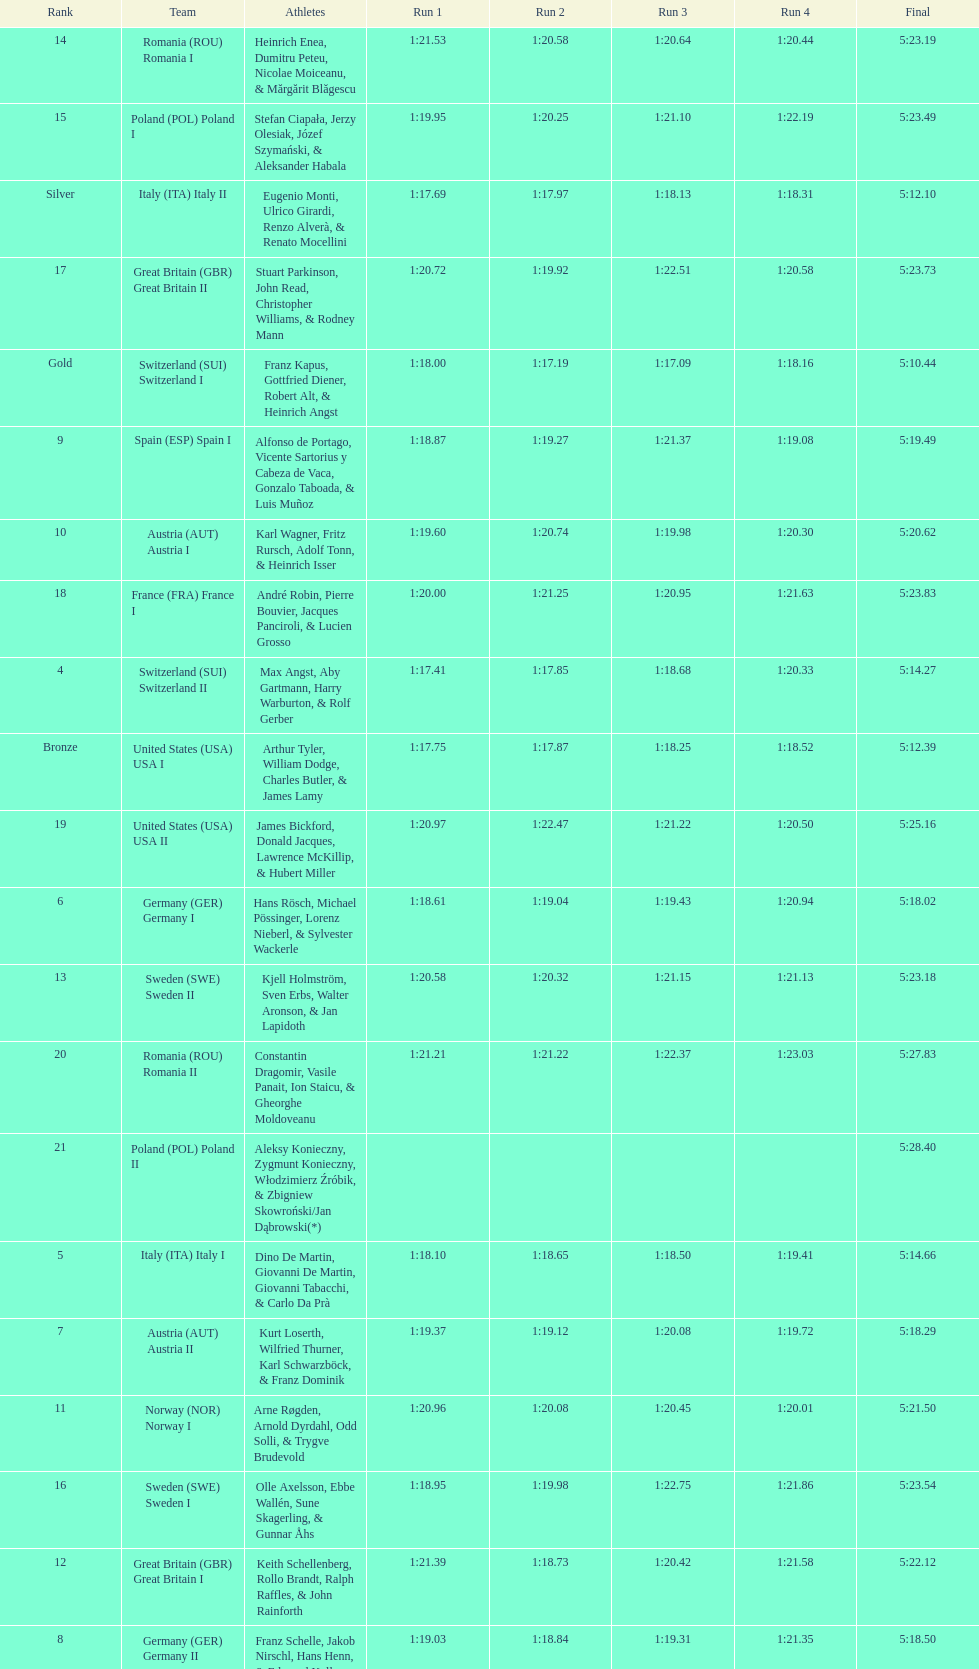How many teams did germany have? 2. 